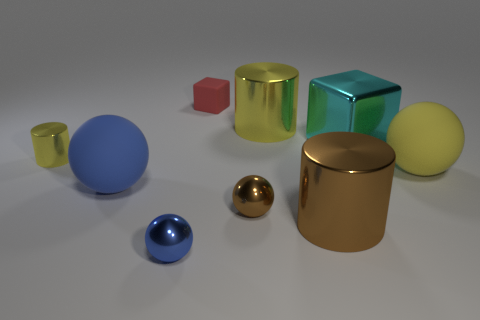What is the material of the small blue sphere?
Your answer should be very brief. Metal. Are there any large rubber balls right of the big brown cylinder?
Your answer should be very brief. Yes. What is the size of the brown thing that is the same shape as the small yellow object?
Your answer should be compact. Large. Are there the same number of cylinders behind the brown ball and yellow things in front of the cyan metal object?
Ensure brevity in your answer.  Yes. What number of metal balls are there?
Offer a terse response. 2. Are there more large yellow cylinders left of the blue metallic sphere than tiny rubber cubes?
Provide a succinct answer. No. What is the big yellow thing behind the tiny yellow shiny thing made of?
Your answer should be very brief. Metal. There is another shiny object that is the same shape as the tiny red thing; what color is it?
Give a very brief answer. Cyan. How many rubber objects are the same color as the tiny cylinder?
Offer a terse response. 1. There is a rubber sphere that is behind the large blue sphere; is its size the same as the yellow shiny cylinder to the left of the big blue rubber ball?
Offer a very short reply. No. 